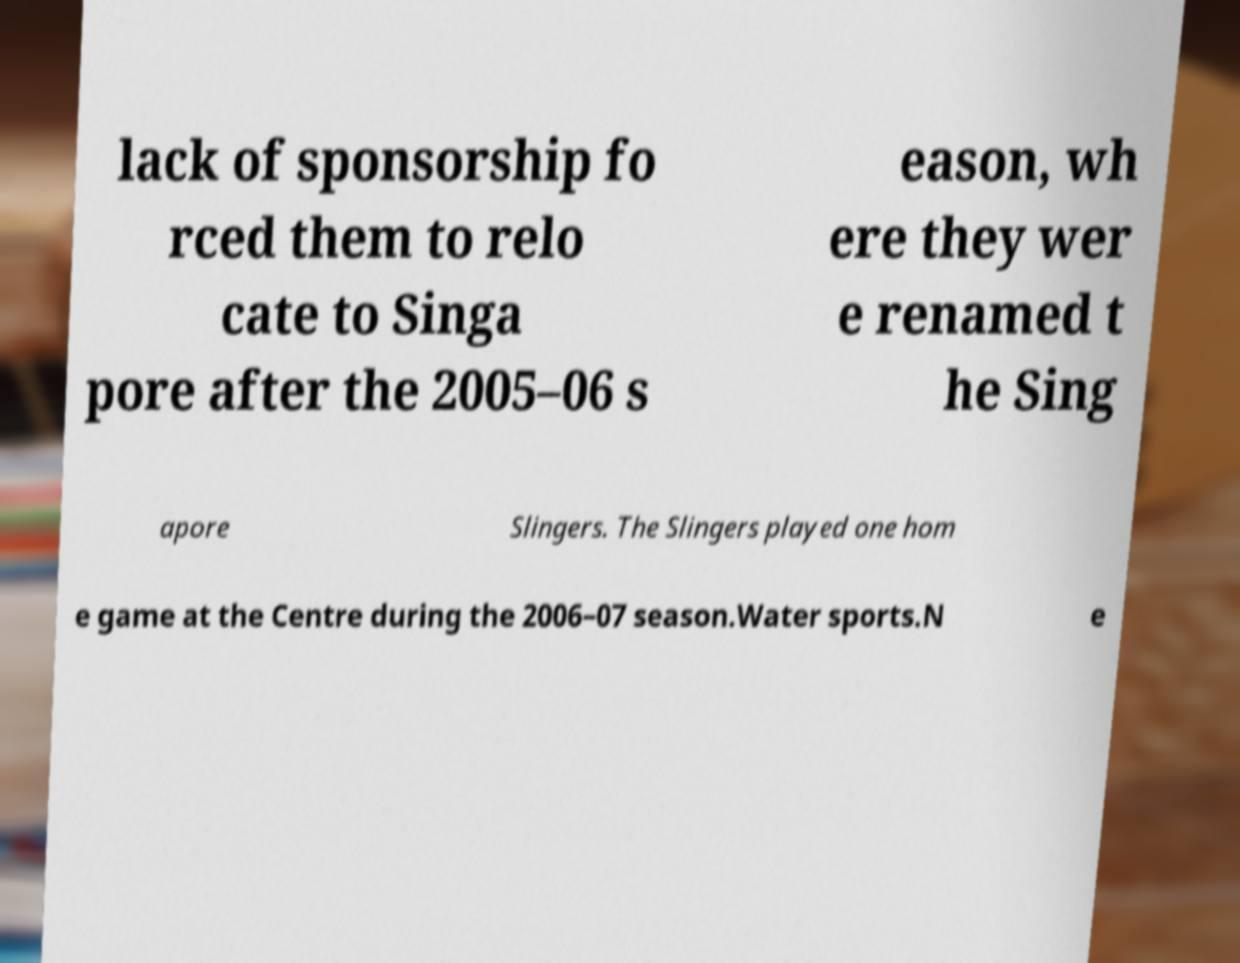For documentation purposes, I need the text within this image transcribed. Could you provide that? lack of sponsorship fo rced them to relo cate to Singa pore after the 2005–06 s eason, wh ere they wer e renamed t he Sing apore Slingers. The Slingers played one hom e game at the Centre during the 2006–07 season.Water sports.N e 